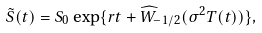Convert formula to latex. <formula><loc_0><loc_0><loc_500><loc_500>\tilde { S } ( t ) = S _ { 0 } \exp \{ r t + \widehat { W } _ { - 1 / 2 } ( \sigma ^ { 2 } T ( t ) ) \} ,</formula> 